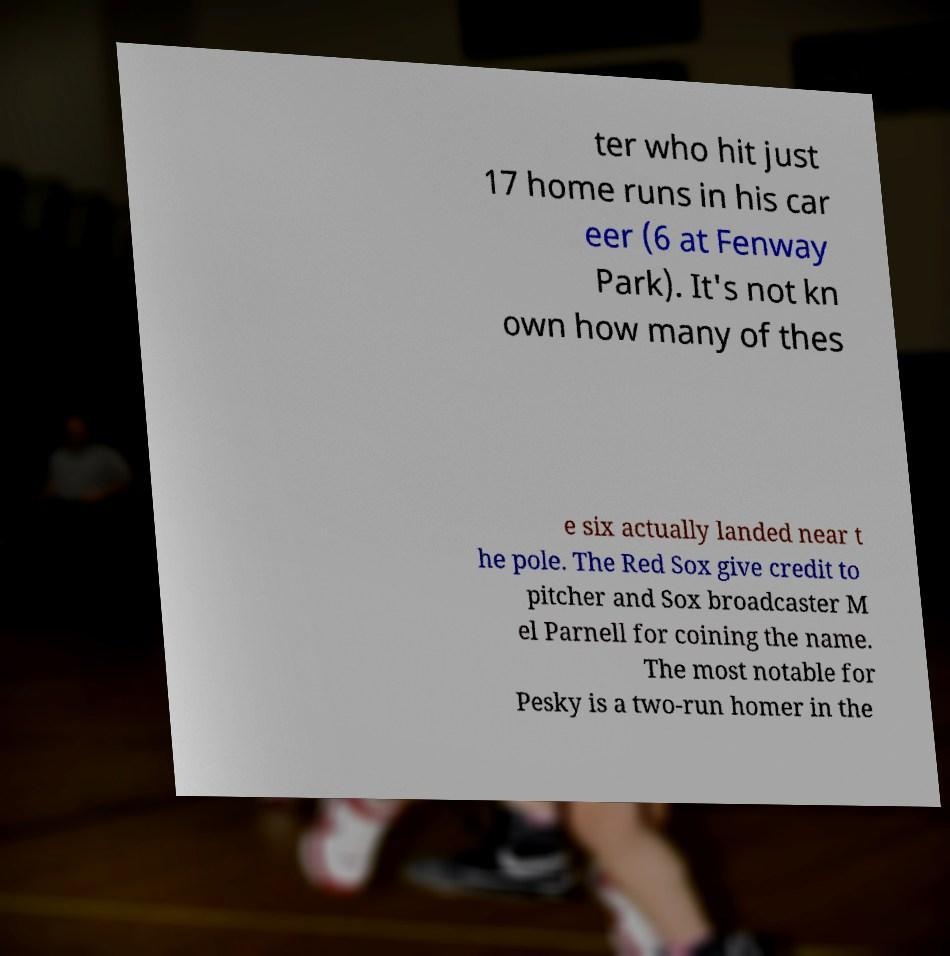What messages or text are displayed in this image? I need them in a readable, typed format. ter who hit just 17 home runs in his car eer (6 at Fenway Park). It's not kn own how many of thes e six actually landed near t he pole. The Red Sox give credit to pitcher and Sox broadcaster M el Parnell for coining the name. The most notable for Pesky is a two-run homer in the 